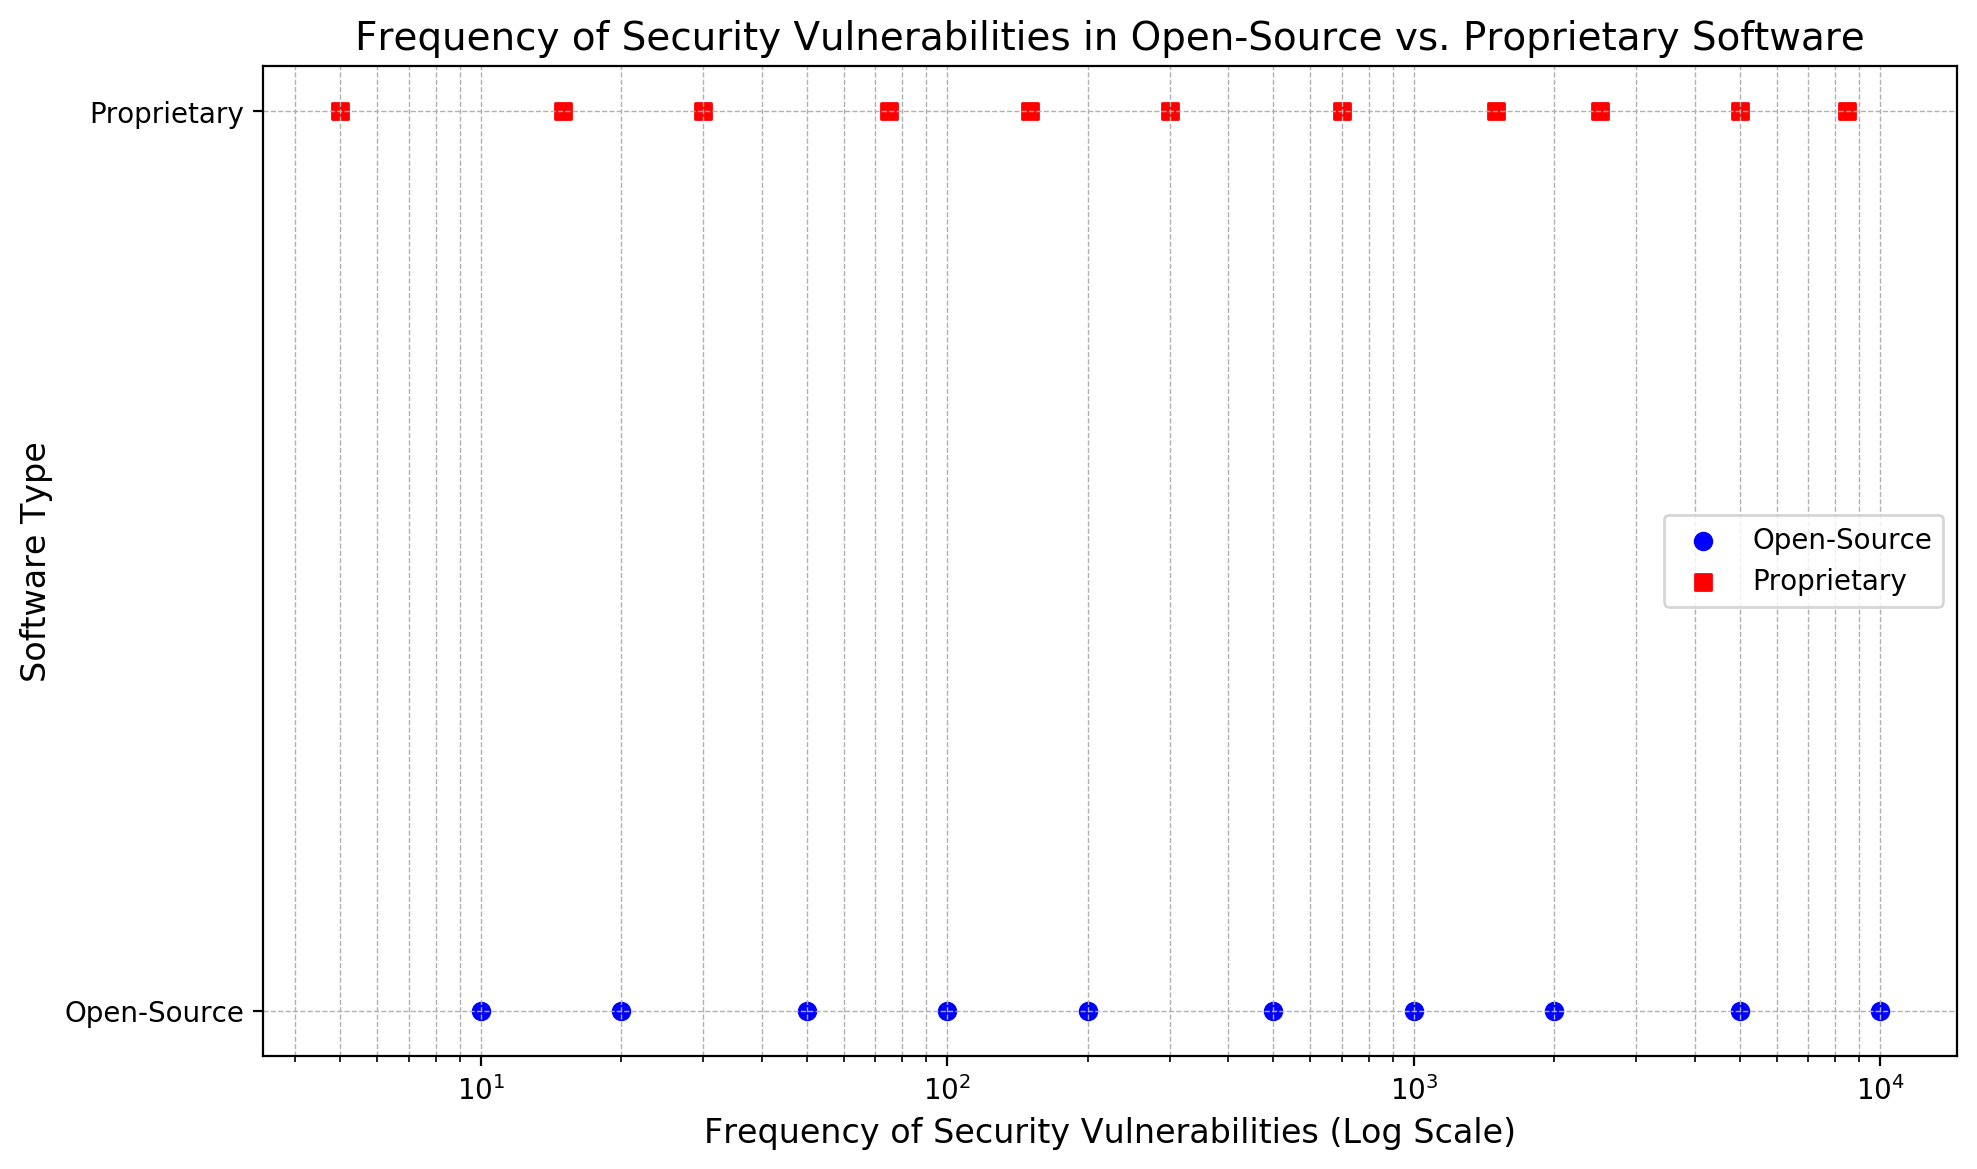What's the highest frequency of security vulnerabilities reported for open-source software? By looking at the scatter plot, for the blue circles representing open-source software, the highest data point is at 10,000 on the x-axis.
Answer: 10,000 What's the lowest frequency of security vulnerabilities reported for proprietary software? In the scatter plot, look for the red squares representing proprietary software. The lowest data point is at 5 on the x-axis.
Answer: 5 How many different frequency points are there in total for proprietary software? Count the number of red squares (proprietary software) on the scatter plot. There are 11 different red squares.
Answer: 11 Which software type has more unique frequency points reported? Compare the number of blue circles (open-source) and red squares (proprietary) on the scatter plot. Open-source has 10, while proprietary has 11.
Answer: Proprietary Do both software types have any data points at the same frequency? Observe if any frequencies (x-axis values) have both a blue circle and a red square. The frequency 5000 appears for both types.
Answer: Yes What is the average of the highest and lowest frequency reported for open-source software? The highest is 10,000 and the lowest is 10. Calculate the average: (10,000 + 10)/2 = 5,005.
Answer: 5,005 How does the maximum frequency of proprietary software compare with the open-source software? The maximum frequency for proprietary software (red squares) is 8,500, while for open-source (blue circles) it is 10,000. Thus, open-source has a higher maximum frequency.
Answer: Open-source is higher What is the difference between the highest frequency in open-source and proprietary software? Subtract the highest proprietary frequency (8,500) from the highest open-source frequency (10,000). The difference is 10,000 - 8,500 = 1,500.
Answer: 1,500 In which range do most of the frequencies for open-source software fall? Most blue circles (open-source) lie in the range from 10 to 1000 on the x-axis.
Answer: 10 to 1000 Which type shows a greater spread in the frequency of security vulnerabilities? By examining the range of the x-axis values, open-source ranges from 10 to 10,000 (spread of 9,990) whereas proprietary ranges from 5 to 8,500 (spread of 8,495). Thus, open-source shows a greater spread.
Answer: Open-source 